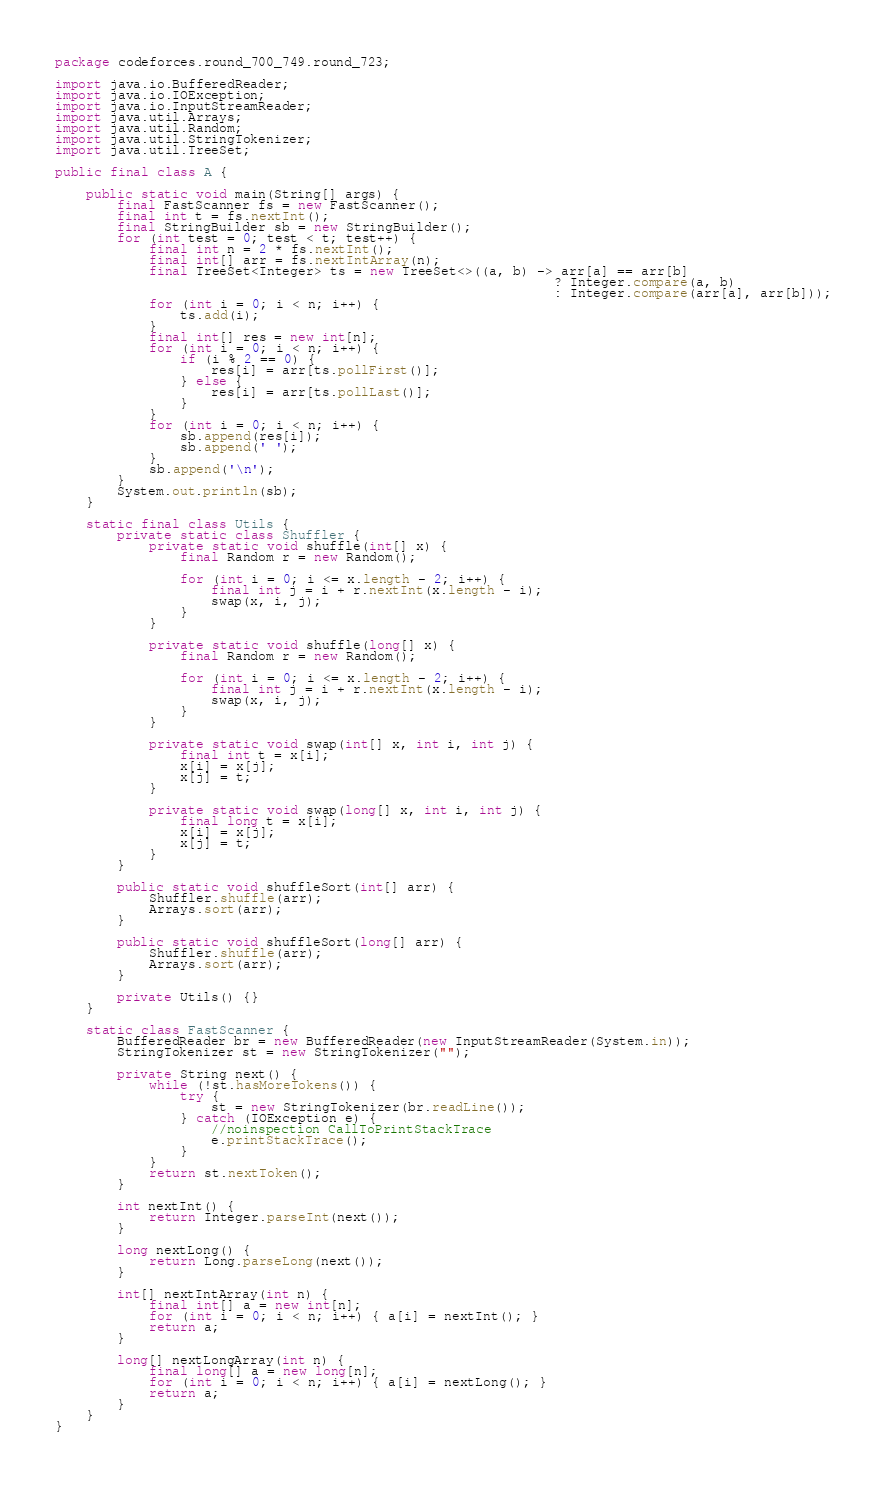<code> <loc_0><loc_0><loc_500><loc_500><_Java_>package codeforces.round_700_749.round_723;

import java.io.BufferedReader;
import java.io.IOException;
import java.io.InputStreamReader;
import java.util.Arrays;
import java.util.Random;
import java.util.StringTokenizer;
import java.util.TreeSet;

public final class A {

    public static void main(String[] args) {
        final FastScanner fs = new FastScanner();
        final int t = fs.nextInt();
        final StringBuilder sb = new StringBuilder();
        for (int test = 0; test < t; test++) {
            final int n = 2 * fs.nextInt();
            final int[] arr = fs.nextIntArray(n);
            final TreeSet<Integer> ts = new TreeSet<>((a, b) -> arr[a] == arr[b]
                                                                ? Integer.compare(a, b)
                                                                : Integer.compare(arr[a], arr[b]));
            for (int i = 0; i < n; i++) {
                ts.add(i);
            }
            final int[] res = new int[n];
            for (int i = 0; i < n; i++) {
                if (i % 2 == 0) {
                    res[i] = arr[ts.pollFirst()];
                } else {
                    res[i] = arr[ts.pollLast()];
                }
            }
            for (int i = 0; i < n; i++) {
                sb.append(res[i]);
                sb.append(' ');
            }
            sb.append('\n');
        }
        System.out.println(sb);
    }

    static final class Utils {
        private static class Shuffler {
            private static void shuffle(int[] x) {
                final Random r = new Random();

                for (int i = 0; i <= x.length - 2; i++) {
                    final int j = i + r.nextInt(x.length - i);
                    swap(x, i, j);
                }
            }

            private static void shuffle(long[] x) {
                final Random r = new Random();

                for (int i = 0; i <= x.length - 2; i++) {
                    final int j = i + r.nextInt(x.length - i);
                    swap(x, i, j);
                }
            }

            private static void swap(int[] x, int i, int j) {
                final int t = x[i];
                x[i] = x[j];
                x[j] = t;
            }

            private static void swap(long[] x, int i, int j) {
                final long t = x[i];
                x[i] = x[j];
                x[j] = t;
            }
        }

        public static void shuffleSort(int[] arr) {
            Shuffler.shuffle(arr);
            Arrays.sort(arr);
        }

        public static void shuffleSort(long[] arr) {
            Shuffler.shuffle(arr);
            Arrays.sort(arr);
        }

        private Utils() {}
    }

    static class FastScanner {
        BufferedReader br = new BufferedReader(new InputStreamReader(System.in));
        StringTokenizer st = new StringTokenizer("");

        private String next() {
            while (!st.hasMoreTokens()) {
                try {
                    st = new StringTokenizer(br.readLine());
                } catch (IOException e) {
                    //noinspection CallToPrintStackTrace
                    e.printStackTrace();
                }
            }
            return st.nextToken();
        }

        int nextInt() {
            return Integer.parseInt(next());
        }

        long nextLong() {
            return Long.parseLong(next());
        }

        int[] nextIntArray(int n) {
            final int[] a = new int[n];
            for (int i = 0; i < n; i++) { a[i] = nextInt(); }
            return a;
        }

        long[] nextLongArray(int n) {
            final long[] a = new long[n];
            for (int i = 0; i < n; i++) { a[i] = nextLong(); }
            return a;
        }
    }
}
</code> 